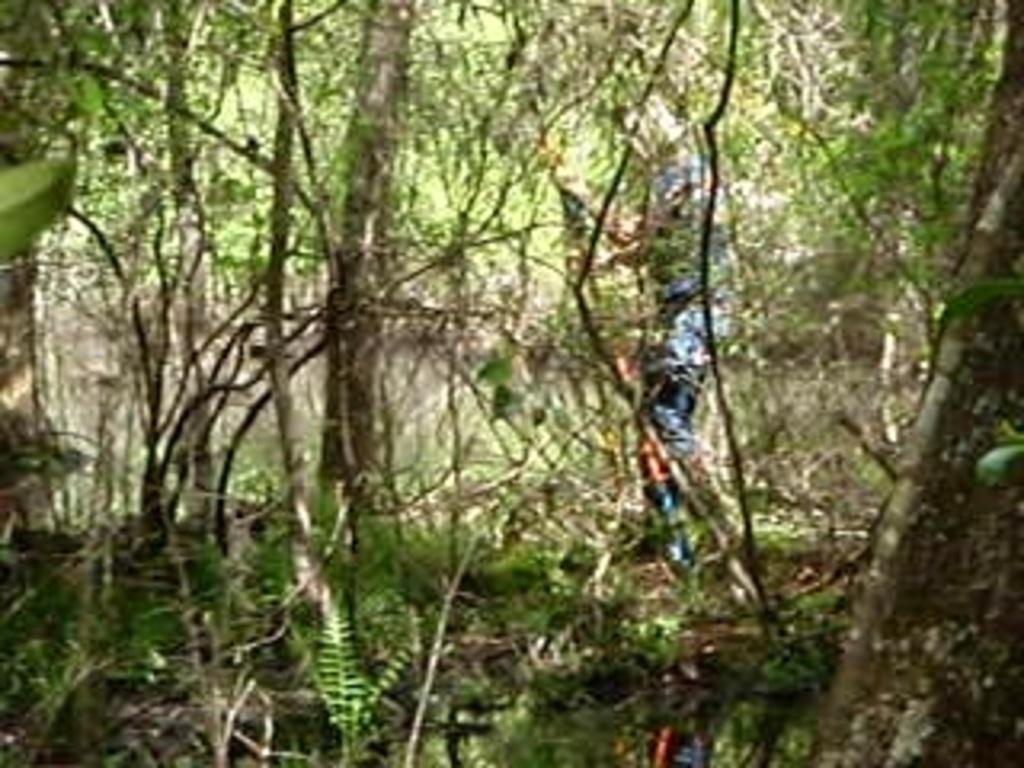In one or two sentences, can you explain what this image depicts? In this image there is a person walking in the forest around him there are so many trees. 